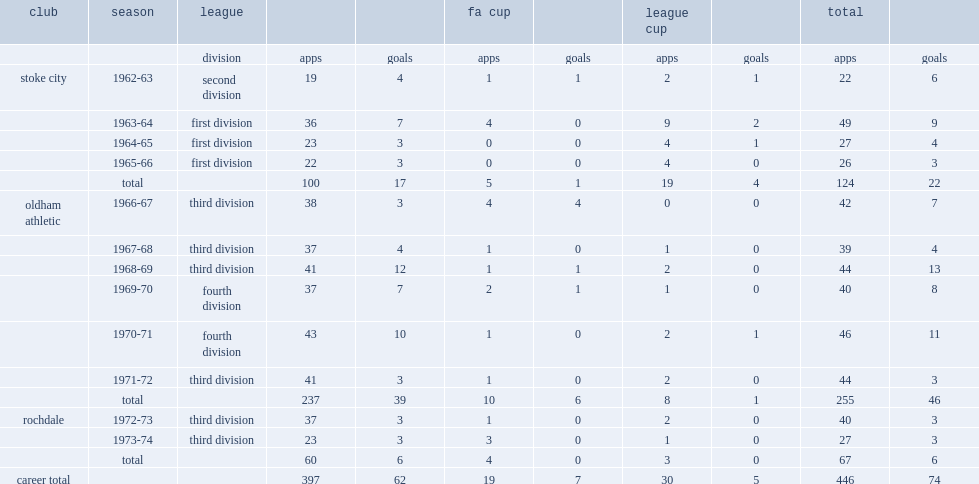How many goals did keith bebbington score for stoke city totally? 22.0. 